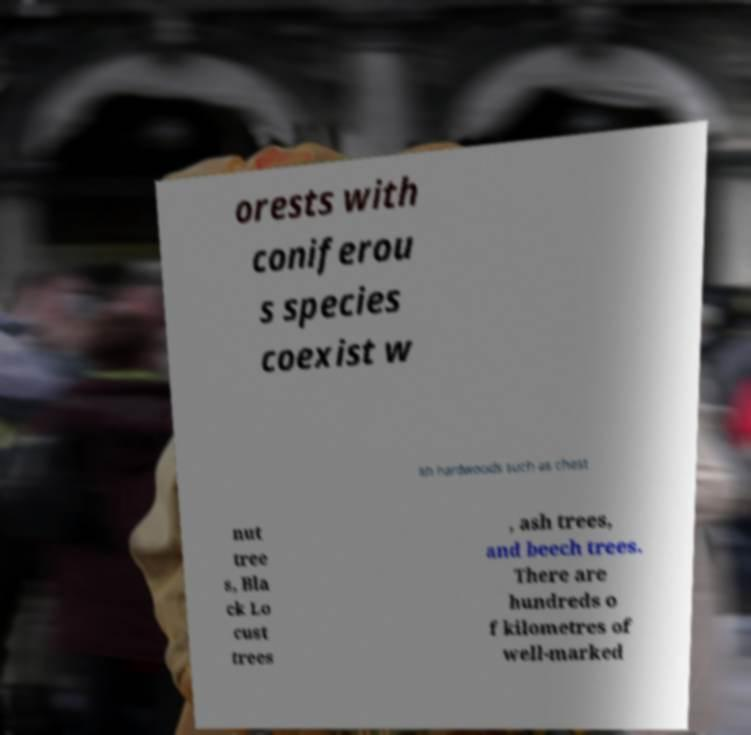Can you accurately transcribe the text from the provided image for me? orests with coniferou s species coexist w ith hardwoods such as chest nut tree s, Bla ck Lo cust trees , ash trees, and beech trees. There are hundreds o f kilometres of well-marked 